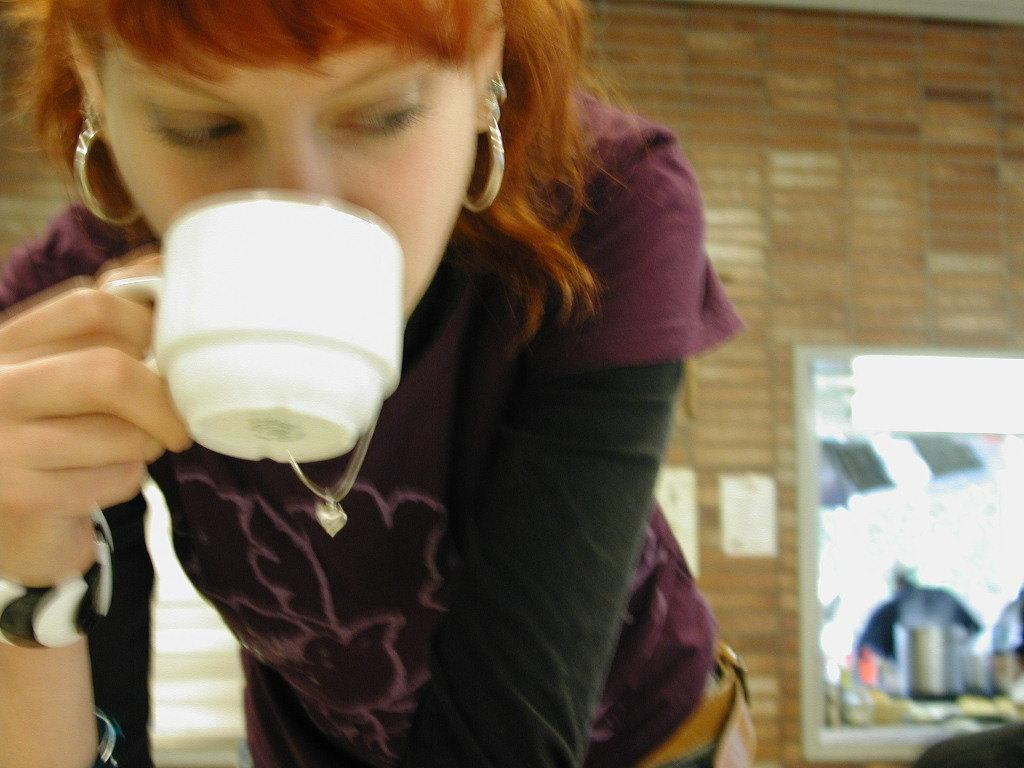Who is present in the image? There is a woman in the image. What is the woman holding in the image? The woman is holding a white color cup. What is the woman doing with the cup? The woman is drinking something from the cup. What can be seen in the background of the image? There is a brick wall in the background of the image. What type of bait is the woman using to catch fish in the image? There is no indication of fishing or bait in the image; the woman is holding a cup and drinking something. 